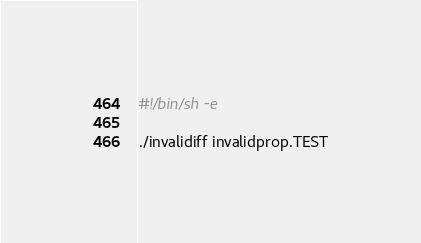<code> <loc_0><loc_0><loc_500><loc_500><_Bash_>#!/bin/sh -e

./invalidiff invalidprop.TEST
</code> 